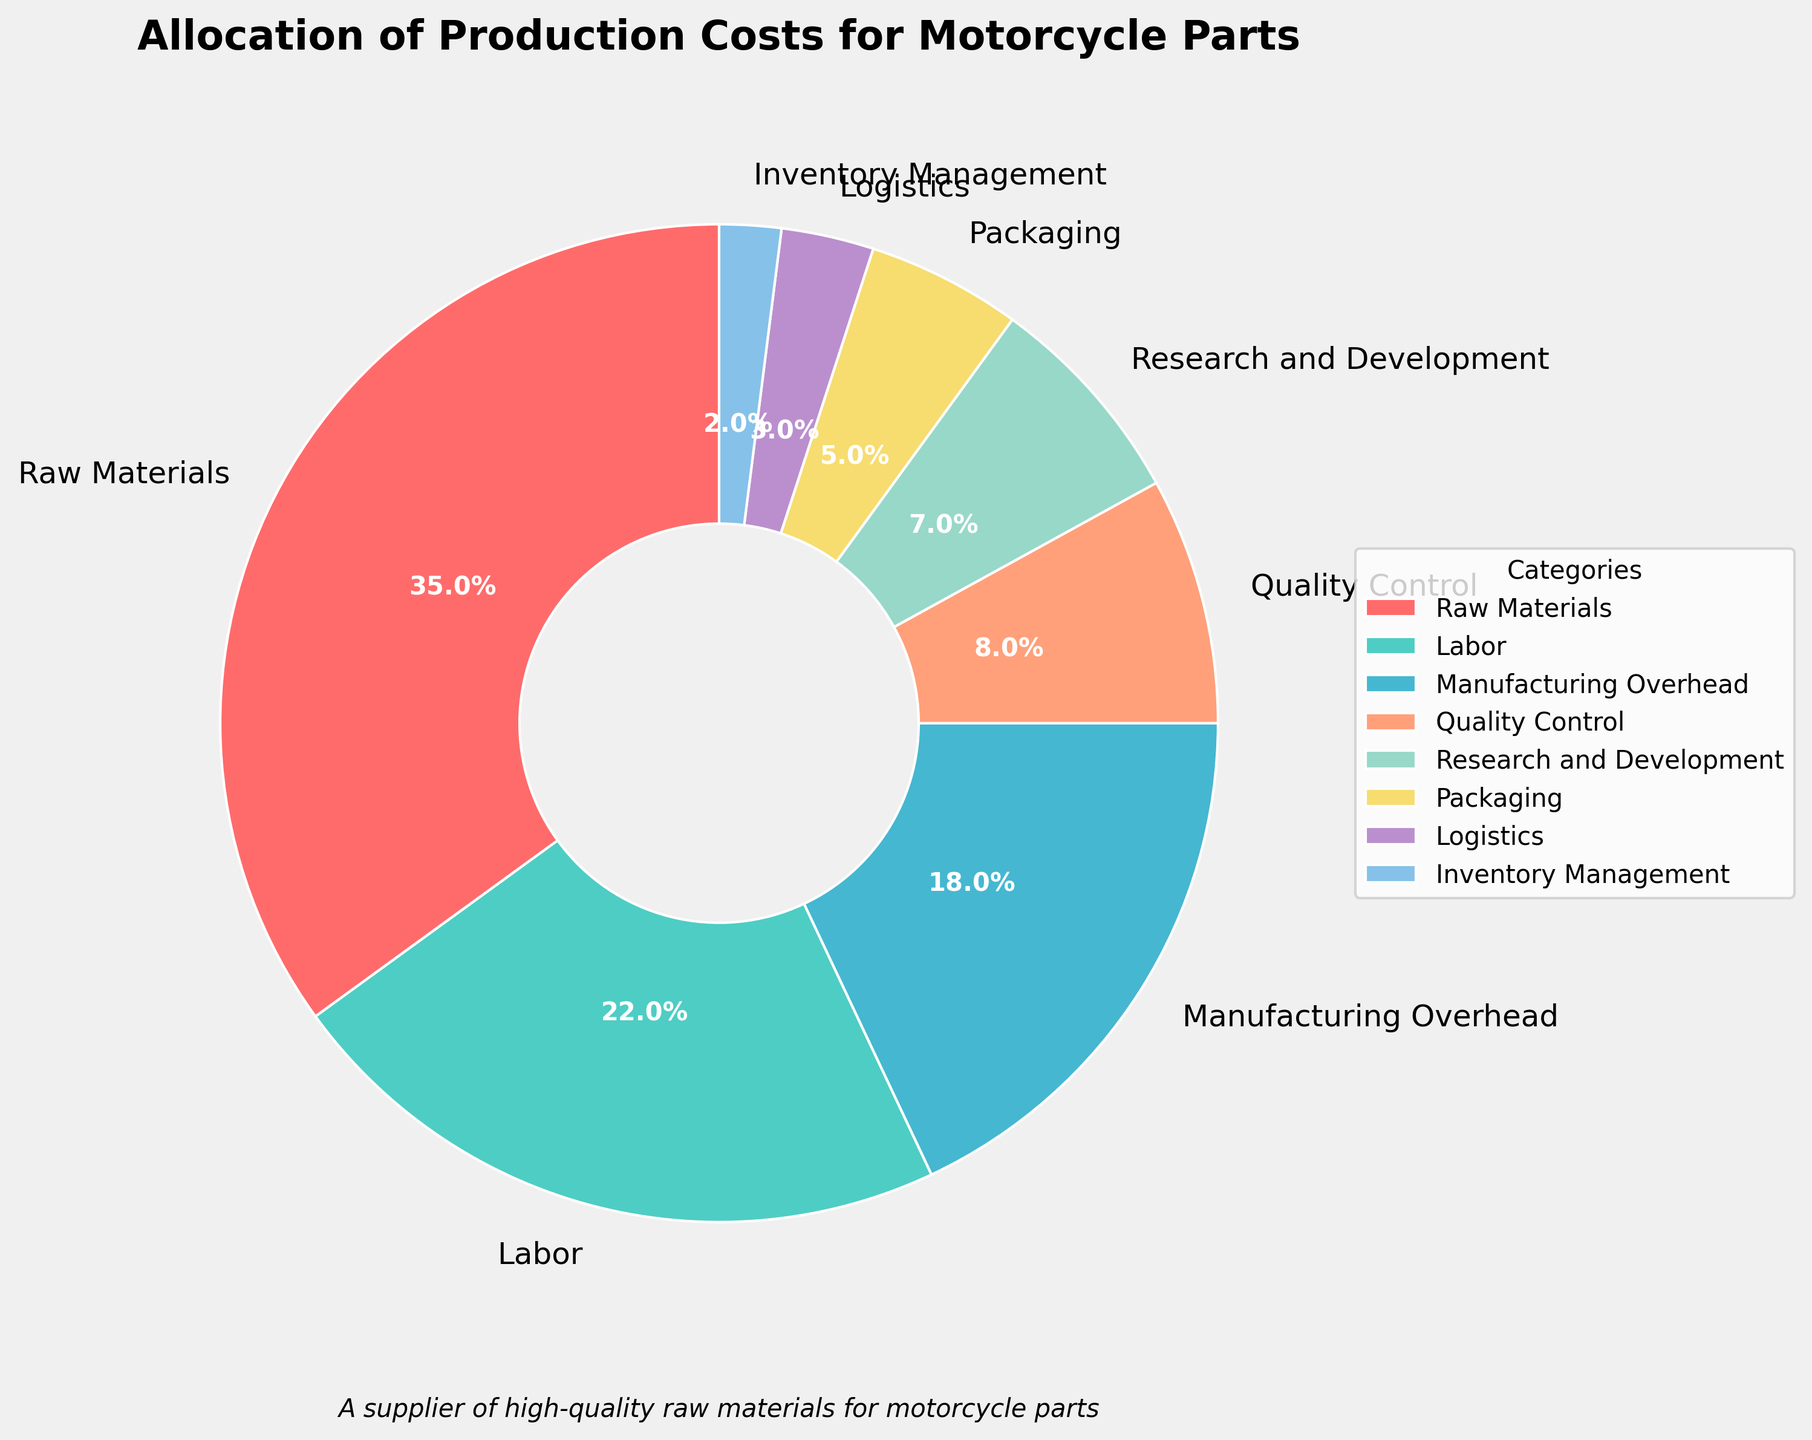What category has the highest allocation in production costs? The figure shows a pie chart with different slices representing the categories and their percentages. The largest slice is for Raw Materials, which is indicated as 35%.
Answer: Raw Materials How much higher is the percentage of Labor costs compared to Manufacturing Overhead? Labor costs are represented by a 22% slice, while Manufacturing Overhead costs are 18%. The difference is 22% - 18%, which is 4%.
Answer: 4% What is the combined percentage of Quality Control, Research and Development, and Packaging costs? The pie chart shows Quality Control at 8%, Research and Development at 7%, and Packaging at 5%. Adding these gives 8% + 7% + 5% = 20%.
Answer: 20% Which category has the smallest allocation, and what is its percentage? The smallest slice, next to Logistics, is Inventory Management with a 2% allocation according to the chart.
Answer: Inventory Management, 2% How does the percentage of Logistics costs compare to that of Packaging costs? The Logistics slice is 3%, while the Packaging slice is 5%. Thus, Logistics costs are 2% less than Packaging costs.
Answer: 2% less Is the percentage of Manufacturing Overhead greater than the combined percentages of Logistics and Inventory Management? Manufacturing Overhead is 18% as per the chart. The combined percentage of Logistics (3%) and Inventory Management (2%) is 3% + 2% = 5%. Since 18% > 5%, the answer is yes.
Answer: Yes What are the colors of the slices representing Research and Development and Labor? The Research and Development slice is represented by a pale yellow color, while Labor is shown in a greenish-teal color.
Answer: pale yellow, greenish-teal What proportion of the total production costs is accounted for by Raw Materials and Labor together? Raw Materials account for 35% and Labor for 22%. Combined, they account for 35% + 22% = 57% of the total production costs.
Answer: 57% How much more is the allocation for Raw Materials compared to the entire Quality Control and Research and Development combined? Raw Materials have a 35% allocation. Quality Control is 8%, and Research and Development is 7%. Combined, they are 8% + 7% = 15%. The difference is 35% - 15% = 20%.
Answer: 20% 